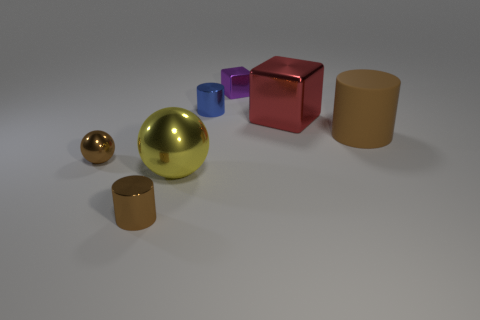Add 2 tiny shiny balls. How many objects exist? 9 Subtract all cubes. How many objects are left? 5 Subtract all purple shiny things. Subtract all big cylinders. How many objects are left? 5 Add 7 blue objects. How many blue objects are left? 8 Add 4 tiny metal objects. How many tiny metal objects exist? 8 Subtract 0 green spheres. How many objects are left? 7 